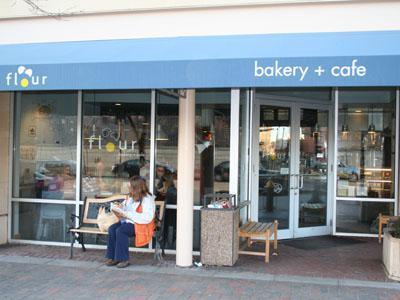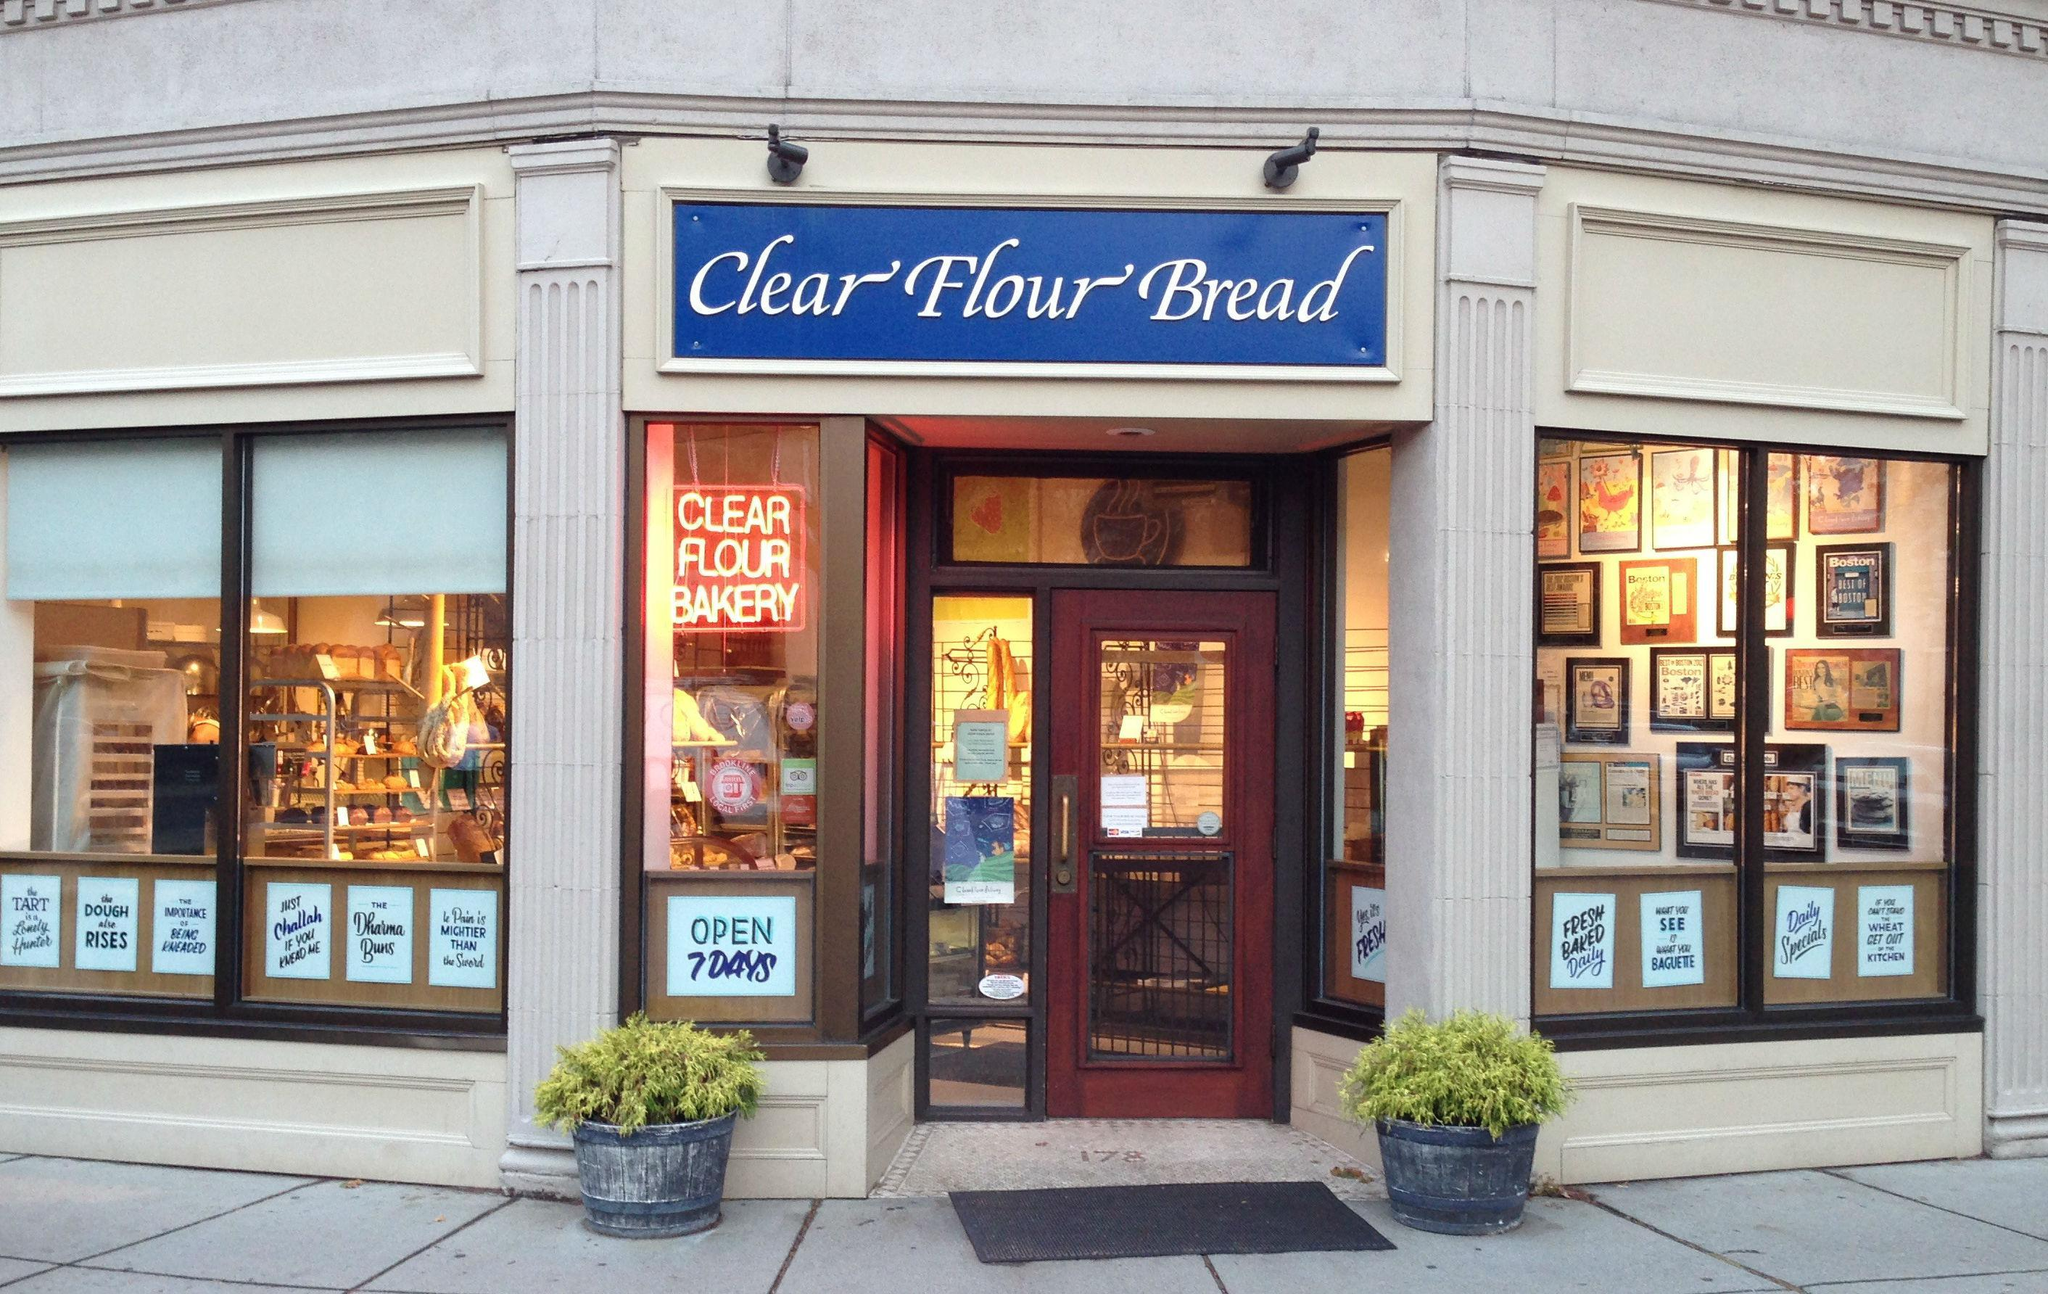The first image is the image on the left, the second image is the image on the right. Considering the images on both sides, is "In at least one image there is a single brown front door under blue signage." valid? Answer yes or no. Yes. The first image is the image on the left, the second image is the image on the right. Considering the images on both sides, is "There is a metal rack with various breads and pastries on it, there are tags in the image on the shelves labeling the products" valid? Answer yes or no. No. 